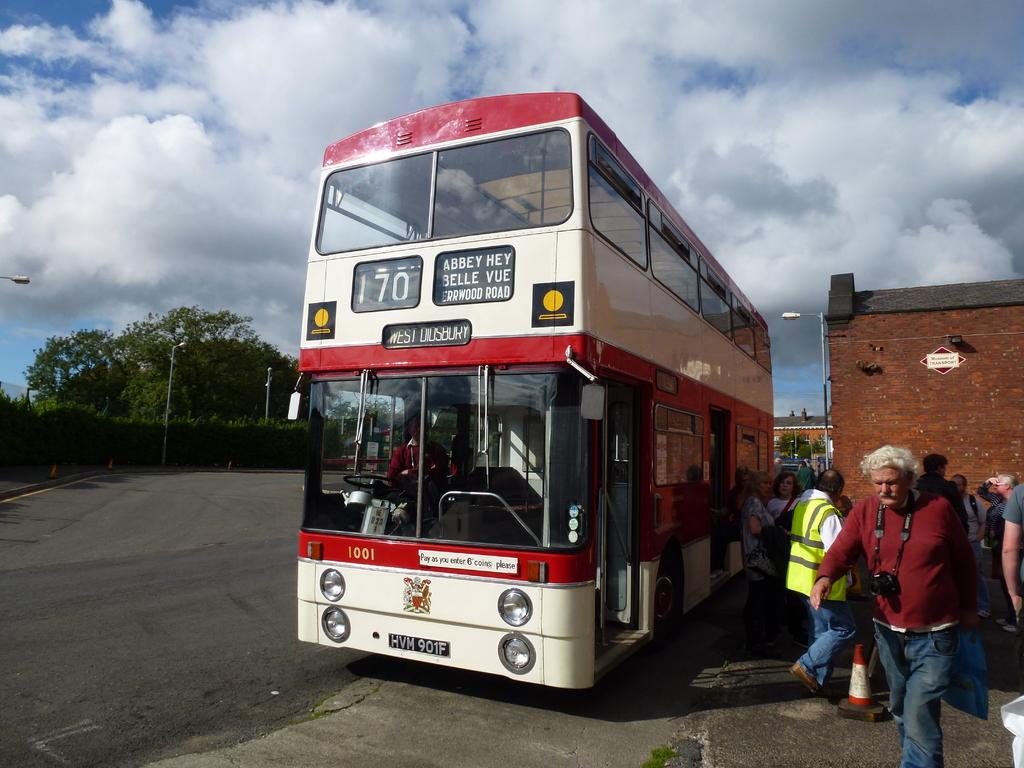Is this bus going to london?
Provide a succinct answer. No. What is the number on the bus?
Ensure brevity in your answer.  70. 